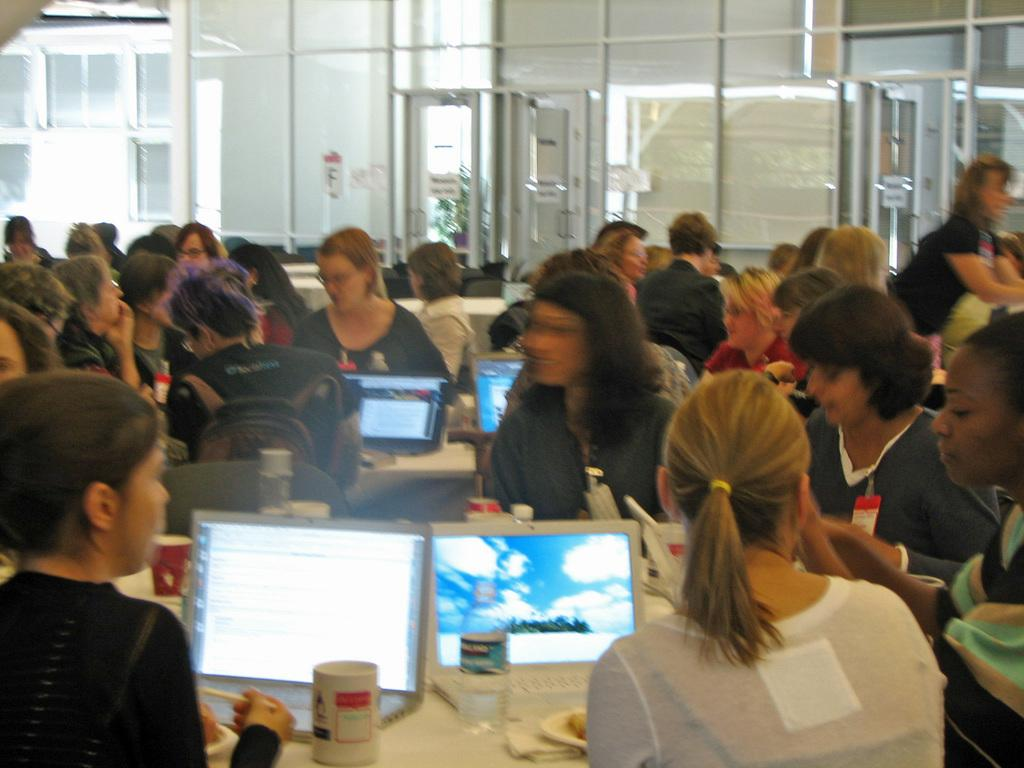How many people are in the image? There is a group of people in the image. What are the people doing in the image? The people are sitting on chairs. What type of furniture can be seen in the image besides chairs? There are tables in the image. What is on the tables in the image? There are screens, mugs, and plates on the tables. Where is the basin located in the image? There is no basin present in the image. How are the people sorting the items on the tables in the image? The people are not sorting items on the tables in the image; they are simply sitting on chairs. 